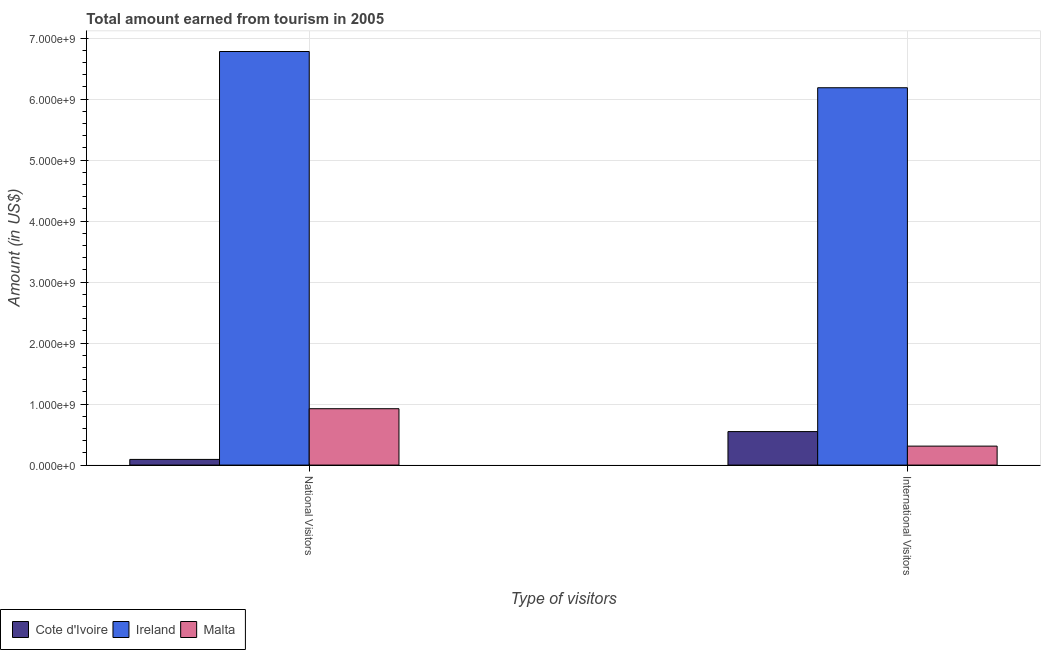How many different coloured bars are there?
Your answer should be compact. 3. Are the number of bars on each tick of the X-axis equal?
Keep it short and to the point. Yes. How many bars are there on the 1st tick from the left?
Provide a succinct answer. 3. What is the label of the 2nd group of bars from the left?
Keep it short and to the point. International Visitors. What is the amount earned from national visitors in Ireland?
Keep it short and to the point. 6.78e+09. Across all countries, what is the maximum amount earned from national visitors?
Your answer should be very brief. 6.78e+09. Across all countries, what is the minimum amount earned from national visitors?
Your response must be concise. 9.30e+07. In which country was the amount earned from international visitors maximum?
Offer a very short reply. Ireland. In which country was the amount earned from international visitors minimum?
Keep it short and to the point. Malta. What is the total amount earned from national visitors in the graph?
Offer a very short reply. 7.80e+09. What is the difference between the amount earned from national visitors in Cote d'Ivoire and that in Malta?
Your answer should be very brief. -8.31e+08. What is the difference between the amount earned from national visitors in Cote d'Ivoire and the amount earned from international visitors in Ireland?
Keep it short and to the point. -6.09e+09. What is the average amount earned from international visitors per country?
Your answer should be very brief. 2.35e+09. What is the difference between the amount earned from national visitors and amount earned from international visitors in Ireland?
Provide a short and direct response. 5.94e+08. In how many countries, is the amount earned from international visitors greater than 1600000000 US$?
Offer a terse response. 1. What is the ratio of the amount earned from national visitors in Malta to that in Cote d'Ivoire?
Your answer should be very brief. 9.94. In how many countries, is the amount earned from national visitors greater than the average amount earned from national visitors taken over all countries?
Provide a succinct answer. 1. What does the 1st bar from the left in International Visitors represents?
Provide a short and direct response. Cote d'Ivoire. What does the 1st bar from the right in National Visitors represents?
Your answer should be compact. Malta. Are all the bars in the graph horizontal?
Your answer should be compact. No. Does the graph contain grids?
Provide a short and direct response. Yes. How are the legend labels stacked?
Keep it short and to the point. Horizontal. What is the title of the graph?
Offer a terse response. Total amount earned from tourism in 2005. Does "Bahamas" appear as one of the legend labels in the graph?
Make the answer very short. No. What is the label or title of the X-axis?
Make the answer very short. Type of visitors. What is the label or title of the Y-axis?
Make the answer very short. Amount (in US$). What is the Amount (in US$) of Cote d'Ivoire in National Visitors?
Offer a very short reply. 9.30e+07. What is the Amount (in US$) of Ireland in National Visitors?
Provide a succinct answer. 6.78e+09. What is the Amount (in US$) in Malta in National Visitors?
Your answer should be very brief. 9.24e+08. What is the Amount (in US$) in Cote d'Ivoire in International Visitors?
Give a very brief answer. 5.49e+08. What is the Amount (in US$) of Ireland in International Visitors?
Ensure brevity in your answer.  6.19e+09. What is the Amount (in US$) of Malta in International Visitors?
Ensure brevity in your answer.  3.11e+08. Across all Type of visitors, what is the maximum Amount (in US$) of Cote d'Ivoire?
Offer a very short reply. 5.49e+08. Across all Type of visitors, what is the maximum Amount (in US$) in Ireland?
Offer a very short reply. 6.78e+09. Across all Type of visitors, what is the maximum Amount (in US$) of Malta?
Your response must be concise. 9.24e+08. Across all Type of visitors, what is the minimum Amount (in US$) of Cote d'Ivoire?
Your answer should be very brief. 9.30e+07. Across all Type of visitors, what is the minimum Amount (in US$) of Ireland?
Ensure brevity in your answer.  6.19e+09. Across all Type of visitors, what is the minimum Amount (in US$) of Malta?
Provide a short and direct response. 3.11e+08. What is the total Amount (in US$) of Cote d'Ivoire in the graph?
Provide a succinct answer. 6.42e+08. What is the total Amount (in US$) of Ireland in the graph?
Offer a terse response. 1.30e+1. What is the total Amount (in US$) of Malta in the graph?
Keep it short and to the point. 1.24e+09. What is the difference between the Amount (in US$) of Cote d'Ivoire in National Visitors and that in International Visitors?
Your answer should be very brief. -4.56e+08. What is the difference between the Amount (in US$) in Ireland in National Visitors and that in International Visitors?
Your answer should be very brief. 5.94e+08. What is the difference between the Amount (in US$) in Malta in National Visitors and that in International Visitors?
Keep it short and to the point. 6.13e+08. What is the difference between the Amount (in US$) in Cote d'Ivoire in National Visitors and the Amount (in US$) in Ireland in International Visitors?
Your response must be concise. -6.09e+09. What is the difference between the Amount (in US$) in Cote d'Ivoire in National Visitors and the Amount (in US$) in Malta in International Visitors?
Offer a terse response. -2.18e+08. What is the difference between the Amount (in US$) in Ireland in National Visitors and the Amount (in US$) in Malta in International Visitors?
Make the answer very short. 6.47e+09. What is the average Amount (in US$) of Cote d'Ivoire per Type of visitors?
Keep it short and to the point. 3.21e+08. What is the average Amount (in US$) in Ireland per Type of visitors?
Make the answer very short. 6.48e+09. What is the average Amount (in US$) in Malta per Type of visitors?
Provide a short and direct response. 6.18e+08. What is the difference between the Amount (in US$) of Cote d'Ivoire and Amount (in US$) of Ireland in National Visitors?
Make the answer very short. -6.69e+09. What is the difference between the Amount (in US$) in Cote d'Ivoire and Amount (in US$) in Malta in National Visitors?
Offer a terse response. -8.31e+08. What is the difference between the Amount (in US$) in Ireland and Amount (in US$) in Malta in National Visitors?
Your answer should be compact. 5.86e+09. What is the difference between the Amount (in US$) of Cote d'Ivoire and Amount (in US$) of Ireland in International Visitors?
Ensure brevity in your answer.  -5.64e+09. What is the difference between the Amount (in US$) of Cote d'Ivoire and Amount (in US$) of Malta in International Visitors?
Offer a very short reply. 2.38e+08. What is the difference between the Amount (in US$) in Ireland and Amount (in US$) in Malta in International Visitors?
Offer a terse response. 5.88e+09. What is the ratio of the Amount (in US$) in Cote d'Ivoire in National Visitors to that in International Visitors?
Your response must be concise. 0.17. What is the ratio of the Amount (in US$) in Ireland in National Visitors to that in International Visitors?
Make the answer very short. 1.1. What is the ratio of the Amount (in US$) in Malta in National Visitors to that in International Visitors?
Offer a terse response. 2.97. What is the difference between the highest and the second highest Amount (in US$) of Cote d'Ivoire?
Offer a very short reply. 4.56e+08. What is the difference between the highest and the second highest Amount (in US$) in Ireland?
Ensure brevity in your answer.  5.94e+08. What is the difference between the highest and the second highest Amount (in US$) of Malta?
Give a very brief answer. 6.13e+08. What is the difference between the highest and the lowest Amount (in US$) in Cote d'Ivoire?
Provide a short and direct response. 4.56e+08. What is the difference between the highest and the lowest Amount (in US$) in Ireland?
Offer a terse response. 5.94e+08. What is the difference between the highest and the lowest Amount (in US$) of Malta?
Provide a short and direct response. 6.13e+08. 